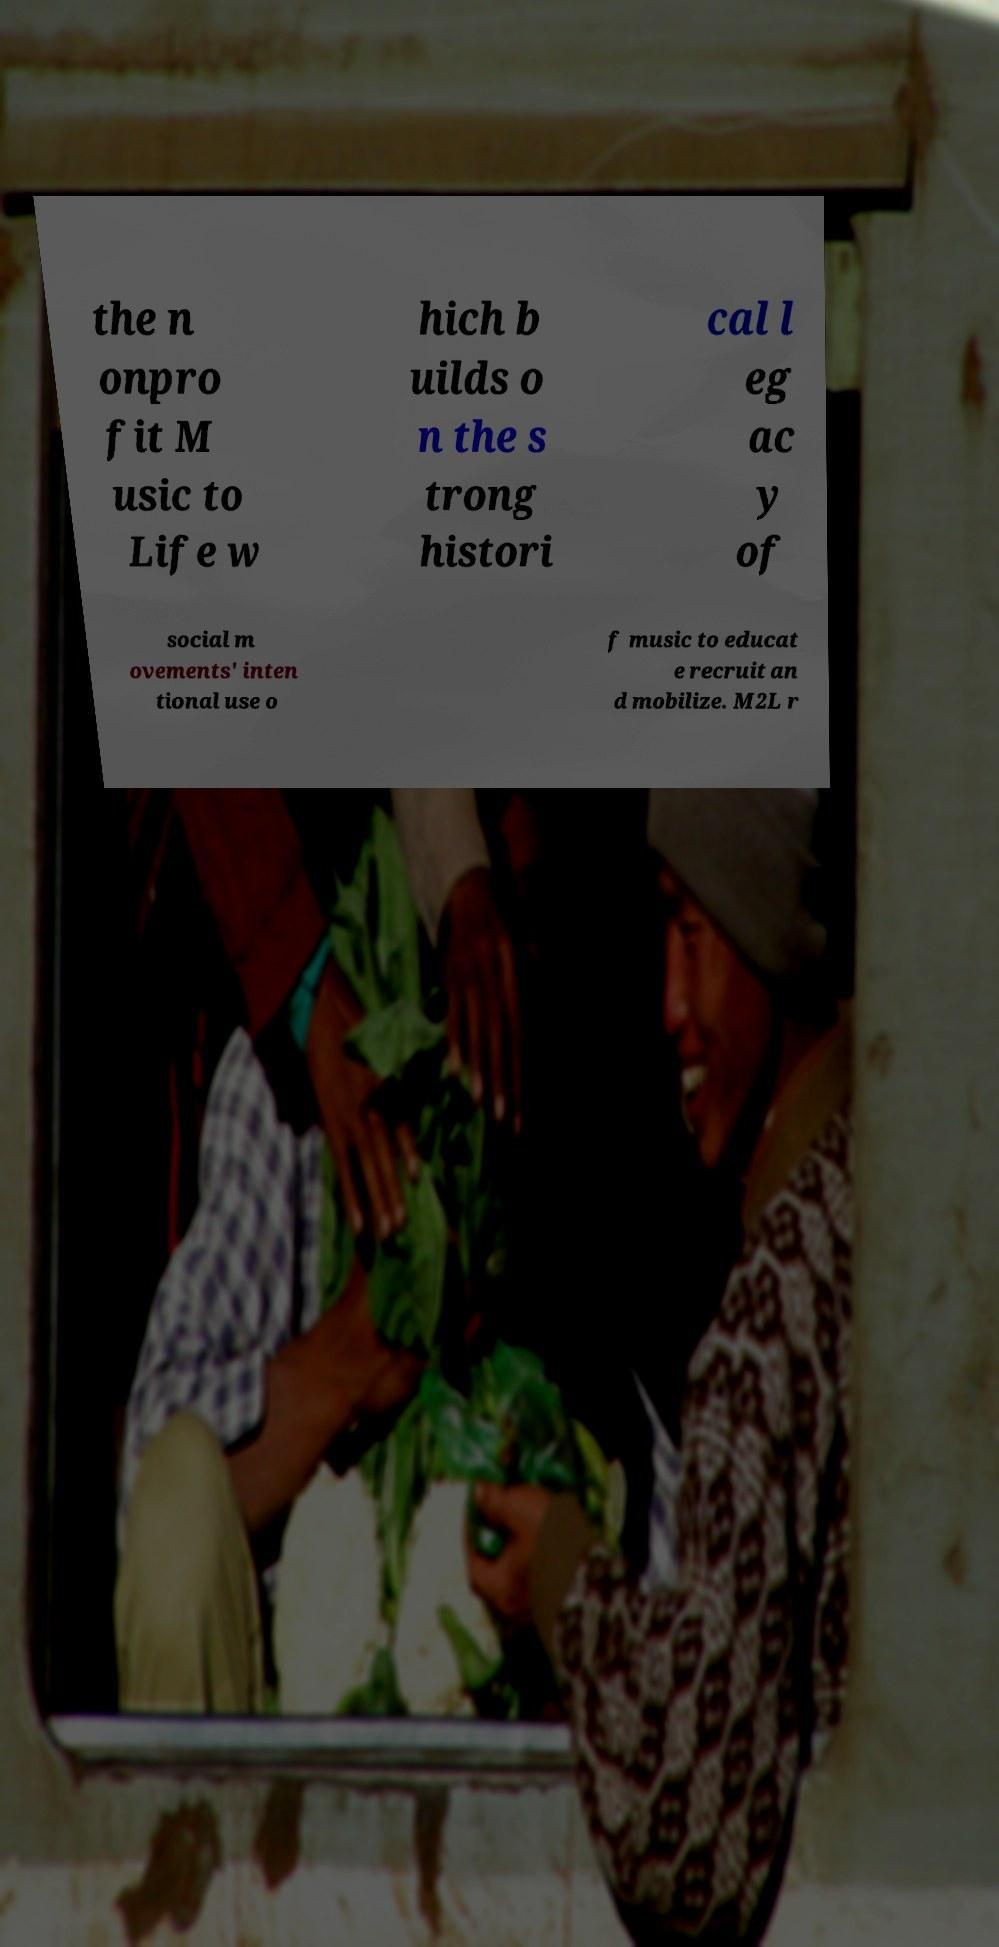There's text embedded in this image that I need extracted. Can you transcribe it verbatim? the n onpro fit M usic to Life w hich b uilds o n the s trong histori cal l eg ac y of social m ovements' inten tional use o f music to educat e recruit an d mobilize. M2L r 